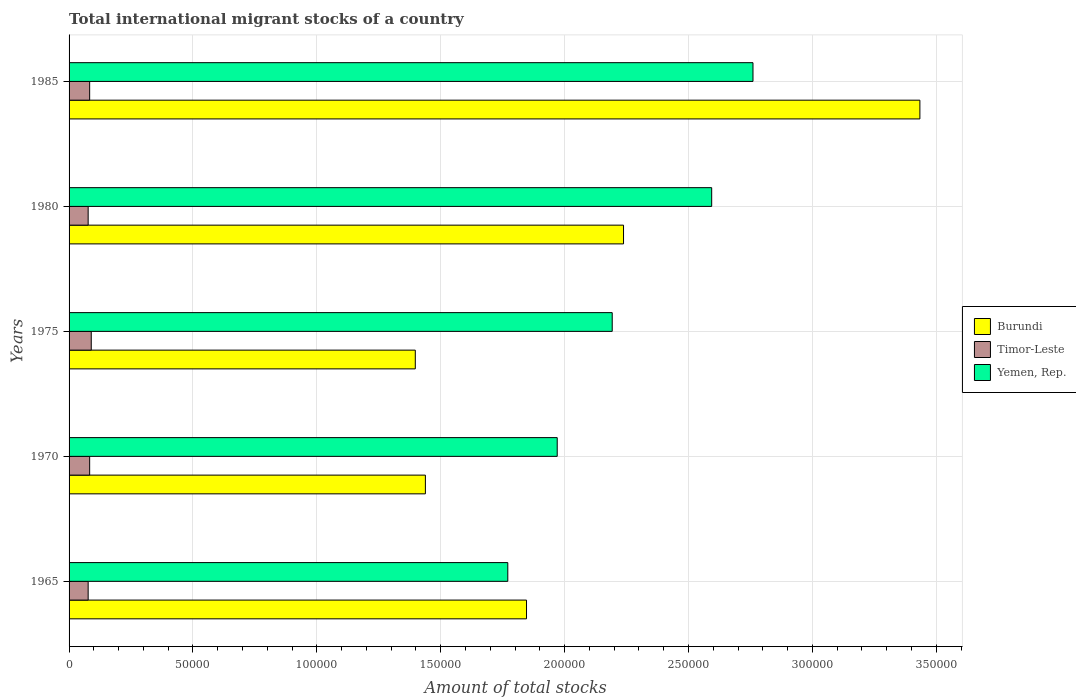How many bars are there on the 5th tick from the bottom?
Make the answer very short. 3. What is the label of the 3rd group of bars from the top?
Ensure brevity in your answer.  1975. What is the amount of total stocks in in Yemen, Rep. in 1965?
Your response must be concise. 1.77e+05. Across all years, what is the maximum amount of total stocks in in Yemen, Rep.?
Make the answer very short. 2.76e+05. Across all years, what is the minimum amount of total stocks in in Timor-Leste?
Your answer should be compact. 7705. In which year was the amount of total stocks in in Yemen, Rep. maximum?
Offer a terse response. 1985. In which year was the amount of total stocks in in Burundi minimum?
Make the answer very short. 1975. What is the total amount of total stocks in in Burundi in the graph?
Provide a short and direct response. 1.04e+06. What is the difference between the amount of total stocks in in Timor-Leste in 1975 and that in 1985?
Offer a terse response. 646. What is the difference between the amount of total stocks in in Timor-Leste in 1985 and the amount of total stocks in in Yemen, Rep. in 1975?
Provide a succinct answer. -2.11e+05. What is the average amount of total stocks in in Burundi per year?
Your answer should be very brief. 2.07e+05. In the year 1970, what is the difference between the amount of total stocks in in Burundi and amount of total stocks in in Yemen, Rep.?
Offer a very short reply. -5.32e+04. In how many years, is the amount of total stocks in in Burundi greater than 40000 ?
Your answer should be compact. 5. What is the ratio of the amount of total stocks in in Yemen, Rep. in 1980 to that in 1985?
Give a very brief answer. 0.94. Is the difference between the amount of total stocks in in Burundi in 1975 and 1985 greater than the difference between the amount of total stocks in in Yemen, Rep. in 1975 and 1985?
Your answer should be very brief. No. What is the difference between the highest and the second highest amount of total stocks in in Burundi?
Provide a short and direct response. 1.20e+05. What is the difference between the highest and the lowest amount of total stocks in in Timor-Leste?
Your answer should be compact. 1248. In how many years, is the amount of total stocks in in Timor-Leste greater than the average amount of total stocks in in Timor-Leste taken over all years?
Give a very brief answer. 3. Is the sum of the amount of total stocks in in Burundi in 1965 and 1975 greater than the maximum amount of total stocks in in Yemen, Rep. across all years?
Provide a short and direct response. Yes. What does the 3rd bar from the top in 1970 represents?
Keep it short and to the point. Burundi. What does the 3rd bar from the bottom in 1985 represents?
Keep it short and to the point. Yemen, Rep. How many bars are there?
Your answer should be very brief. 15. How many years are there in the graph?
Your response must be concise. 5. What is the difference between two consecutive major ticks on the X-axis?
Your answer should be very brief. 5.00e+04. Does the graph contain any zero values?
Offer a terse response. No. Does the graph contain grids?
Offer a terse response. Yes. What is the title of the graph?
Provide a succinct answer. Total international migrant stocks of a country. What is the label or title of the X-axis?
Provide a succinct answer. Amount of total stocks. What is the label or title of the Y-axis?
Provide a short and direct response. Years. What is the Amount of total stocks of Burundi in 1965?
Offer a very short reply. 1.85e+05. What is the Amount of total stocks of Timor-Leste in 1965?
Offer a terse response. 7705. What is the Amount of total stocks in Yemen, Rep. in 1965?
Make the answer very short. 1.77e+05. What is the Amount of total stocks of Burundi in 1970?
Offer a very short reply. 1.44e+05. What is the Amount of total stocks in Timor-Leste in 1970?
Give a very brief answer. 8306. What is the Amount of total stocks in Yemen, Rep. in 1970?
Your response must be concise. 1.97e+05. What is the Amount of total stocks of Burundi in 1975?
Keep it short and to the point. 1.40e+05. What is the Amount of total stocks of Timor-Leste in 1975?
Your response must be concise. 8953. What is the Amount of total stocks in Yemen, Rep. in 1975?
Your response must be concise. 2.19e+05. What is the Amount of total stocks in Burundi in 1980?
Provide a short and direct response. 2.24e+05. What is the Amount of total stocks of Timor-Leste in 1980?
Ensure brevity in your answer.  7706. What is the Amount of total stocks in Yemen, Rep. in 1980?
Provide a succinct answer. 2.59e+05. What is the Amount of total stocks in Burundi in 1985?
Make the answer very short. 3.43e+05. What is the Amount of total stocks of Timor-Leste in 1985?
Your answer should be very brief. 8307. What is the Amount of total stocks in Yemen, Rep. in 1985?
Your response must be concise. 2.76e+05. Across all years, what is the maximum Amount of total stocks in Burundi?
Provide a succinct answer. 3.43e+05. Across all years, what is the maximum Amount of total stocks of Timor-Leste?
Your answer should be compact. 8953. Across all years, what is the maximum Amount of total stocks in Yemen, Rep.?
Give a very brief answer. 2.76e+05. Across all years, what is the minimum Amount of total stocks in Burundi?
Offer a very short reply. 1.40e+05. Across all years, what is the minimum Amount of total stocks in Timor-Leste?
Ensure brevity in your answer.  7705. Across all years, what is the minimum Amount of total stocks in Yemen, Rep.?
Keep it short and to the point. 1.77e+05. What is the total Amount of total stocks in Burundi in the graph?
Ensure brevity in your answer.  1.04e+06. What is the total Amount of total stocks in Timor-Leste in the graph?
Give a very brief answer. 4.10e+04. What is the total Amount of total stocks in Yemen, Rep. in the graph?
Your answer should be very brief. 1.13e+06. What is the difference between the Amount of total stocks of Burundi in 1965 and that in 1970?
Your response must be concise. 4.08e+04. What is the difference between the Amount of total stocks of Timor-Leste in 1965 and that in 1970?
Keep it short and to the point. -601. What is the difference between the Amount of total stocks of Yemen, Rep. in 1965 and that in 1970?
Ensure brevity in your answer.  -1.99e+04. What is the difference between the Amount of total stocks in Burundi in 1965 and that in 1975?
Provide a succinct answer. 4.49e+04. What is the difference between the Amount of total stocks in Timor-Leste in 1965 and that in 1975?
Give a very brief answer. -1248. What is the difference between the Amount of total stocks in Yemen, Rep. in 1965 and that in 1975?
Provide a short and direct response. -4.21e+04. What is the difference between the Amount of total stocks of Burundi in 1965 and that in 1980?
Give a very brief answer. -3.92e+04. What is the difference between the Amount of total stocks in Yemen, Rep. in 1965 and that in 1980?
Offer a very short reply. -8.23e+04. What is the difference between the Amount of total stocks in Burundi in 1965 and that in 1985?
Provide a succinct answer. -1.59e+05. What is the difference between the Amount of total stocks in Timor-Leste in 1965 and that in 1985?
Give a very brief answer. -602. What is the difference between the Amount of total stocks in Yemen, Rep. in 1965 and that in 1985?
Give a very brief answer. -9.90e+04. What is the difference between the Amount of total stocks in Burundi in 1970 and that in 1975?
Offer a very short reply. 4079. What is the difference between the Amount of total stocks in Timor-Leste in 1970 and that in 1975?
Offer a terse response. -647. What is the difference between the Amount of total stocks in Yemen, Rep. in 1970 and that in 1975?
Ensure brevity in your answer.  -2.22e+04. What is the difference between the Amount of total stocks of Burundi in 1970 and that in 1980?
Your answer should be very brief. -8.00e+04. What is the difference between the Amount of total stocks of Timor-Leste in 1970 and that in 1980?
Ensure brevity in your answer.  600. What is the difference between the Amount of total stocks of Yemen, Rep. in 1970 and that in 1980?
Provide a succinct answer. -6.23e+04. What is the difference between the Amount of total stocks in Burundi in 1970 and that in 1985?
Give a very brief answer. -2.00e+05. What is the difference between the Amount of total stocks in Yemen, Rep. in 1970 and that in 1985?
Your answer should be compact. -7.90e+04. What is the difference between the Amount of total stocks of Burundi in 1975 and that in 1980?
Your answer should be very brief. -8.40e+04. What is the difference between the Amount of total stocks in Timor-Leste in 1975 and that in 1980?
Make the answer very short. 1247. What is the difference between the Amount of total stocks in Yemen, Rep. in 1975 and that in 1980?
Offer a terse response. -4.02e+04. What is the difference between the Amount of total stocks of Burundi in 1975 and that in 1985?
Provide a short and direct response. -2.04e+05. What is the difference between the Amount of total stocks of Timor-Leste in 1975 and that in 1985?
Make the answer very short. 646. What is the difference between the Amount of total stocks in Yemen, Rep. in 1975 and that in 1985?
Make the answer very short. -5.68e+04. What is the difference between the Amount of total stocks in Burundi in 1980 and that in 1985?
Offer a terse response. -1.20e+05. What is the difference between the Amount of total stocks of Timor-Leste in 1980 and that in 1985?
Ensure brevity in your answer.  -601. What is the difference between the Amount of total stocks of Yemen, Rep. in 1980 and that in 1985?
Your answer should be very brief. -1.67e+04. What is the difference between the Amount of total stocks of Burundi in 1965 and the Amount of total stocks of Timor-Leste in 1970?
Your answer should be compact. 1.76e+05. What is the difference between the Amount of total stocks in Burundi in 1965 and the Amount of total stocks in Yemen, Rep. in 1970?
Ensure brevity in your answer.  -1.24e+04. What is the difference between the Amount of total stocks in Timor-Leste in 1965 and the Amount of total stocks in Yemen, Rep. in 1970?
Provide a succinct answer. -1.89e+05. What is the difference between the Amount of total stocks of Burundi in 1965 and the Amount of total stocks of Timor-Leste in 1975?
Provide a short and direct response. 1.76e+05. What is the difference between the Amount of total stocks of Burundi in 1965 and the Amount of total stocks of Yemen, Rep. in 1975?
Provide a short and direct response. -3.46e+04. What is the difference between the Amount of total stocks in Timor-Leste in 1965 and the Amount of total stocks in Yemen, Rep. in 1975?
Your answer should be compact. -2.12e+05. What is the difference between the Amount of total stocks in Burundi in 1965 and the Amount of total stocks in Timor-Leste in 1980?
Provide a succinct answer. 1.77e+05. What is the difference between the Amount of total stocks in Burundi in 1965 and the Amount of total stocks in Yemen, Rep. in 1980?
Your answer should be very brief. -7.47e+04. What is the difference between the Amount of total stocks of Timor-Leste in 1965 and the Amount of total stocks of Yemen, Rep. in 1980?
Ensure brevity in your answer.  -2.52e+05. What is the difference between the Amount of total stocks of Burundi in 1965 and the Amount of total stocks of Timor-Leste in 1985?
Give a very brief answer. 1.76e+05. What is the difference between the Amount of total stocks of Burundi in 1965 and the Amount of total stocks of Yemen, Rep. in 1985?
Your response must be concise. -9.14e+04. What is the difference between the Amount of total stocks in Timor-Leste in 1965 and the Amount of total stocks in Yemen, Rep. in 1985?
Provide a succinct answer. -2.68e+05. What is the difference between the Amount of total stocks of Burundi in 1970 and the Amount of total stocks of Timor-Leste in 1975?
Offer a very short reply. 1.35e+05. What is the difference between the Amount of total stocks of Burundi in 1970 and the Amount of total stocks of Yemen, Rep. in 1975?
Give a very brief answer. -7.54e+04. What is the difference between the Amount of total stocks of Timor-Leste in 1970 and the Amount of total stocks of Yemen, Rep. in 1975?
Ensure brevity in your answer.  -2.11e+05. What is the difference between the Amount of total stocks of Burundi in 1970 and the Amount of total stocks of Timor-Leste in 1980?
Provide a succinct answer. 1.36e+05. What is the difference between the Amount of total stocks in Burundi in 1970 and the Amount of total stocks in Yemen, Rep. in 1980?
Your answer should be compact. -1.16e+05. What is the difference between the Amount of total stocks of Timor-Leste in 1970 and the Amount of total stocks of Yemen, Rep. in 1980?
Offer a terse response. -2.51e+05. What is the difference between the Amount of total stocks in Burundi in 1970 and the Amount of total stocks in Timor-Leste in 1985?
Ensure brevity in your answer.  1.36e+05. What is the difference between the Amount of total stocks in Burundi in 1970 and the Amount of total stocks in Yemen, Rep. in 1985?
Provide a succinct answer. -1.32e+05. What is the difference between the Amount of total stocks of Timor-Leste in 1970 and the Amount of total stocks of Yemen, Rep. in 1985?
Provide a short and direct response. -2.68e+05. What is the difference between the Amount of total stocks in Burundi in 1975 and the Amount of total stocks in Timor-Leste in 1980?
Give a very brief answer. 1.32e+05. What is the difference between the Amount of total stocks in Burundi in 1975 and the Amount of total stocks in Yemen, Rep. in 1980?
Keep it short and to the point. -1.20e+05. What is the difference between the Amount of total stocks in Timor-Leste in 1975 and the Amount of total stocks in Yemen, Rep. in 1980?
Offer a terse response. -2.50e+05. What is the difference between the Amount of total stocks of Burundi in 1975 and the Amount of total stocks of Timor-Leste in 1985?
Provide a succinct answer. 1.31e+05. What is the difference between the Amount of total stocks of Burundi in 1975 and the Amount of total stocks of Yemen, Rep. in 1985?
Make the answer very short. -1.36e+05. What is the difference between the Amount of total stocks of Timor-Leste in 1975 and the Amount of total stocks of Yemen, Rep. in 1985?
Make the answer very short. -2.67e+05. What is the difference between the Amount of total stocks of Burundi in 1980 and the Amount of total stocks of Timor-Leste in 1985?
Make the answer very short. 2.15e+05. What is the difference between the Amount of total stocks in Burundi in 1980 and the Amount of total stocks in Yemen, Rep. in 1985?
Provide a short and direct response. -5.22e+04. What is the difference between the Amount of total stocks of Timor-Leste in 1980 and the Amount of total stocks of Yemen, Rep. in 1985?
Make the answer very short. -2.68e+05. What is the average Amount of total stocks in Burundi per year?
Make the answer very short. 2.07e+05. What is the average Amount of total stocks in Timor-Leste per year?
Your response must be concise. 8195.4. What is the average Amount of total stocks in Yemen, Rep. per year?
Offer a terse response. 2.26e+05. In the year 1965, what is the difference between the Amount of total stocks in Burundi and Amount of total stocks in Timor-Leste?
Make the answer very short. 1.77e+05. In the year 1965, what is the difference between the Amount of total stocks in Burundi and Amount of total stocks in Yemen, Rep.?
Your response must be concise. 7557. In the year 1965, what is the difference between the Amount of total stocks of Timor-Leste and Amount of total stocks of Yemen, Rep.?
Keep it short and to the point. -1.69e+05. In the year 1970, what is the difference between the Amount of total stocks in Burundi and Amount of total stocks in Timor-Leste?
Your answer should be very brief. 1.36e+05. In the year 1970, what is the difference between the Amount of total stocks of Burundi and Amount of total stocks of Yemen, Rep.?
Provide a short and direct response. -5.32e+04. In the year 1970, what is the difference between the Amount of total stocks of Timor-Leste and Amount of total stocks of Yemen, Rep.?
Give a very brief answer. -1.89e+05. In the year 1975, what is the difference between the Amount of total stocks of Burundi and Amount of total stocks of Timor-Leste?
Ensure brevity in your answer.  1.31e+05. In the year 1975, what is the difference between the Amount of total stocks of Burundi and Amount of total stocks of Yemen, Rep.?
Give a very brief answer. -7.95e+04. In the year 1975, what is the difference between the Amount of total stocks in Timor-Leste and Amount of total stocks in Yemen, Rep.?
Your answer should be very brief. -2.10e+05. In the year 1980, what is the difference between the Amount of total stocks of Burundi and Amount of total stocks of Timor-Leste?
Give a very brief answer. 2.16e+05. In the year 1980, what is the difference between the Amount of total stocks in Burundi and Amount of total stocks in Yemen, Rep.?
Make the answer very short. -3.56e+04. In the year 1980, what is the difference between the Amount of total stocks in Timor-Leste and Amount of total stocks in Yemen, Rep.?
Give a very brief answer. -2.52e+05. In the year 1985, what is the difference between the Amount of total stocks in Burundi and Amount of total stocks in Timor-Leste?
Give a very brief answer. 3.35e+05. In the year 1985, what is the difference between the Amount of total stocks in Burundi and Amount of total stocks in Yemen, Rep.?
Provide a short and direct response. 6.74e+04. In the year 1985, what is the difference between the Amount of total stocks in Timor-Leste and Amount of total stocks in Yemen, Rep.?
Your answer should be compact. -2.68e+05. What is the ratio of the Amount of total stocks in Burundi in 1965 to that in 1970?
Provide a short and direct response. 1.28. What is the ratio of the Amount of total stocks in Timor-Leste in 1965 to that in 1970?
Offer a terse response. 0.93. What is the ratio of the Amount of total stocks of Yemen, Rep. in 1965 to that in 1970?
Keep it short and to the point. 0.9. What is the ratio of the Amount of total stocks of Burundi in 1965 to that in 1975?
Keep it short and to the point. 1.32. What is the ratio of the Amount of total stocks in Timor-Leste in 1965 to that in 1975?
Provide a succinct answer. 0.86. What is the ratio of the Amount of total stocks in Yemen, Rep. in 1965 to that in 1975?
Offer a very short reply. 0.81. What is the ratio of the Amount of total stocks of Burundi in 1965 to that in 1980?
Give a very brief answer. 0.82. What is the ratio of the Amount of total stocks of Yemen, Rep. in 1965 to that in 1980?
Ensure brevity in your answer.  0.68. What is the ratio of the Amount of total stocks of Burundi in 1965 to that in 1985?
Provide a short and direct response. 0.54. What is the ratio of the Amount of total stocks of Timor-Leste in 1965 to that in 1985?
Your answer should be compact. 0.93. What is the ratio of the Amount of total stocks in Yemen, Rep. in 1965 to that in 1985?
Offer a very short reply. 0.64. What is the ratio of the Amount of total stocks in Burundi in 1970 to that in 1975?
Make the answer very short. 1.03. What is the ratio of the Amount of total stocks of Timor-Leste in 1970 to that in 1975?
Offer a very short reply. 0.93. What is the ratio of the Amount of total stocks in Yemen, Rep. in 1970 to that in 1975?
Offer a very short reply. 0.9. What is the ratio of the Amount of total stocks in Burundi in 1970 to that in 1980?
Ensure brevity in your answer.  0.64. What is the ratio of the Amount of total stocks in Timor-Leste in 1970 to that in 1980?
Provide a succinct answer. 1.08. What is the ratio of the Amount of total stocks of Yemen, Rep. in 1970 to that in 1980?
Provide a succinct answer. 0.76. What is the ratio of the Amount of total stocks of Burundi in 1970 to that in 1985?
Offer a very short reply. 0.42. What is the ratio of the Amount of total stocks of Yemen, Rep. in 1970 to that in 1985?
Your answer should be compact. 0.71. What is the ratio of the Amount of total stocks of Burundi in 1975 to that in 1980?
Provide a short and direct response. 0.62. What is the ratio of the Amount of total stocks in Timor-Leste in 1975 to that in 1980?
Keep it short and to the point. 1.16. What is the ratio of the Amount of total stocks in Yemen, Rep. in 1975 to that in 1980?
Your answer should be very brief. 0.85. What is the ratio of the Amount of total stocks in Burundi in 1975 to that in 1985?
Make the answer very short. 0.41. What is the ratio of the Amount of total stocks of Timor-Leste in 1975 to that in 1985?
Offer a terse response. 1.08. What is the ratio of the Amount of total stocks in Yemen, Rep. in 1975 to that in 1985?
Your response must be concise. 0.79. What is the ratio of the Amount of total stocks of Burundi in 1980 to that in 1985?
Your answer should be very brief. 0.65. What is the ratio of the Amount of total stocks of Timor-Leste in 1980 to that in 1985?
Make the answer very short. 0.93. What is the ratio of the Amount of total stocks in Yemen, Rep. in 1980 to that in 1985?
Your answer should be compact. 0.94. What is the difference between the highest and the second highest Amount of total stocks of Burundi?
Provide a succinct answer. 1.20e+05. What is the difference between the highest and the second highest Amount of total stocks of Timor-Leste?
Offer a very short reply. 646. What is the difference between the highest and the second highest Amount of total stocks of Yemen, Rep.?
Give a very brief answer. 1.67e+04. What is the difference between the highest and the lowest Amount of total stocks in Burundi?
Give a very brief answer. 2.04e+05. What is the difference between the highest and the lowest Amount of total stocks in Timor-Leste?
Offer a very short reply. 1248. What is the difference between the highest and the lowest Amount of total stocks of Yemen, Rep.?
Make the answer very short. 9.90e+04. 